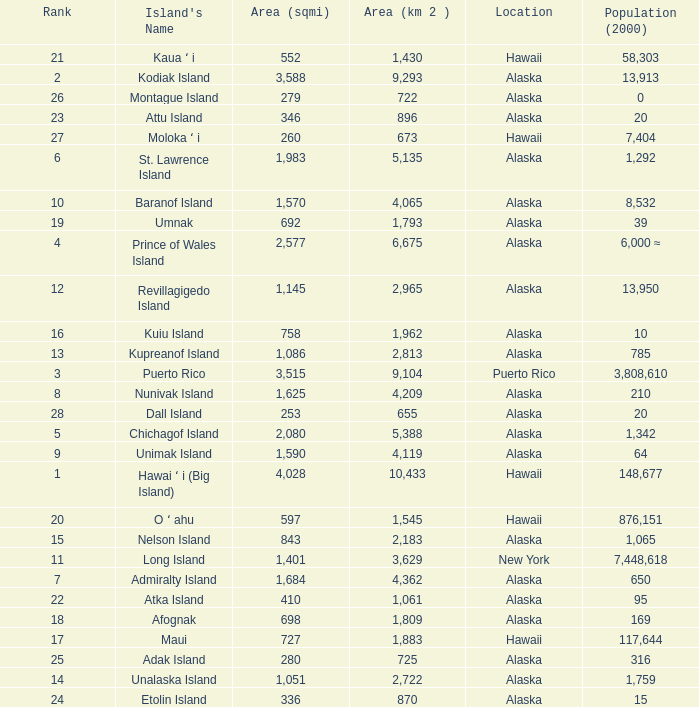What is the largest rank with 2,080 area? 5.0. Would you be able to parse every entry in this table? {'header': ['Rank', "Island's Name", 'Area (sqmi)', 'Area (km 2 )', 'Location', 'Population (2000)'], 'rows': [['21', 'Kaua ʻ i', '552', '1,430', 'Hawaii', '58,303'], ['2', 'Kodiak Island', '3,588', '9,293', 'Alaska', '13,913'], ['26', 'Montague Island', '279', '722', 'Alaska', '0'], ['23', 'Attu Island', '346', '896', 'Alaska', '20'], ['27', 'Moloka ʻ i', '260', '673', 'Hawaii', '7,404'], ['6', 'St. Lawrence Island', '1,983', '5,135', 'Alaska', '1,292'], ['10', 'Baranof Island', '1,570', '4,065', 'Alaska', '8,532'], ['19', 'Umnak', '692', '1,793', 'Alaska', '39'], ['4', 'Prince of Wales Island', '2,577', '6,675', 'Alaska', '6,000 ≈'], ['12', 'Revillagigedo Island', '1,145', '2,965', 'Alaska', '13,950'], ['16', 'Kuiu Island', '758', '1,962', 'Alaska', '10'], ['13', 'Kupreanof Island', '1,086', '2,813', 'Alaska', '785'], ['3', 'Puerto Rico', '3,515', '9,104', 'Puerto Rico', '3,808,610'], ['8', 'Nunivak Island', '1,625', '4,209', 'Alaska', '210'], ['28', 'Dall Island', '253', '655', 'Alaska', '20'], ['5', 'Chichagof Island', '2,080', '5,388', 'Alaska', '1,342'], ['9', 'Unimak Island', '1,590', '4,119', 'Alaska', '64'], ['1', 'Hawai ʻ i (Big Island)', '4,028', '10,433', 'Hawaii', '148,677'], ['20', 'O ʻ ahu', '597', '1,545', 'Hawaii', '876,151'], ['15', 'Nelson Island', '843', '2,183', 'Alaska', '1,065'], ['11', 'Long Island', '1,401', '3,629', 'New York', '7,448,618'], ['7', 'Admiralty Island', '1,684', '4,362', 'Alaska', '650'], ['22', 'Atka Island', '410', '1,061', 'Alaska', '95'], ['18', 'Afognak', '698', '1,809', 'Alaska', '169'], ['17', 'Maui', '727', '1,883', 'Hawaii', '117,644'], ['25', 'Adak Island', '280', '725', 'Alaska', '316'], ['14', 'Unalaska Island', '1,051', '2,722', 'Alaska', '1,759'], ['24', 'Etolin Island', '336', '870', 'Alaska', '15']]} 